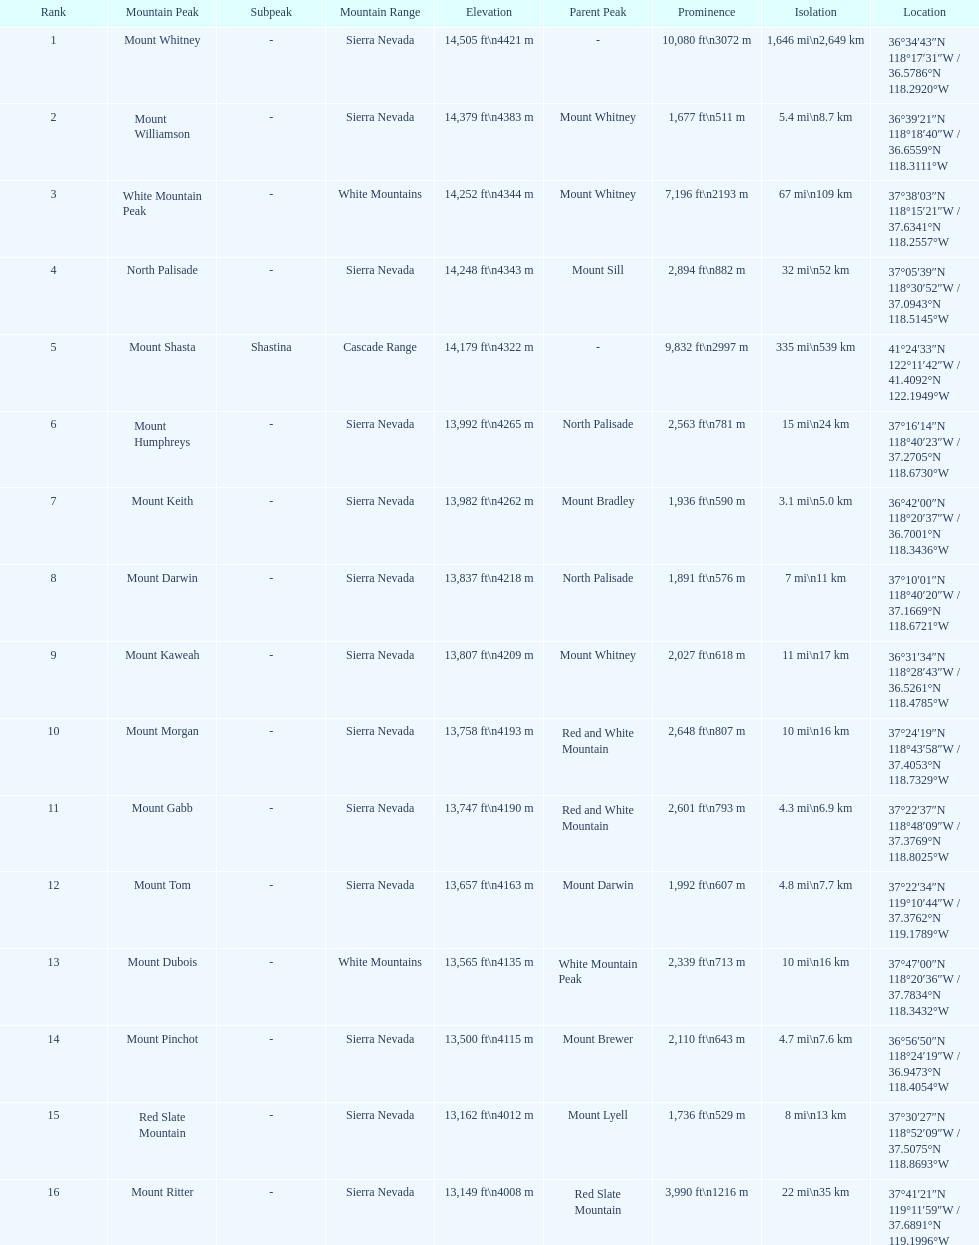What is the next highest mountain peak after north palisade? Mount Shasta. 